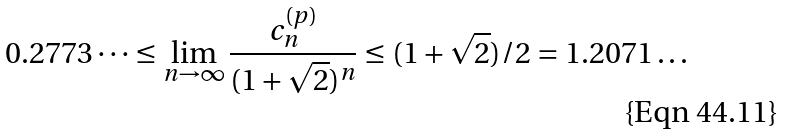<formula> <loc_0><loc_0><loc_500><loc_500>0 . 2 7 7 3 \dots \leq \lim _ { n \to \infty } \frac { c _ { n } ^ { ( p ) } } { ( 1 + \sqrt { 2 } ) ^ { n } } \leq ( 1 + \sqrt { 2 } ) / 2 = 1 . 2 0 7 1 \dots</formula> 